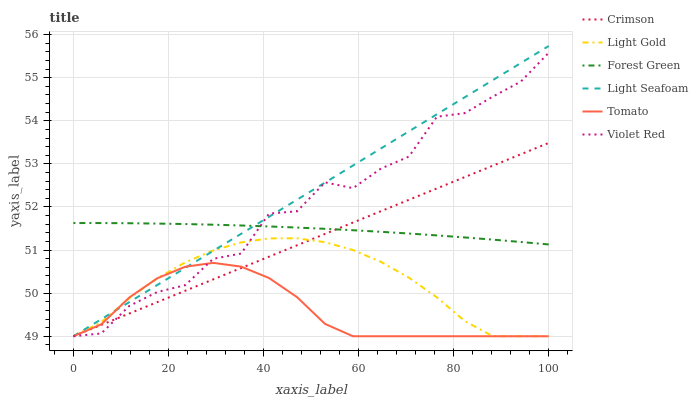Does Violet Red have the minimum area under the curve?
Answer yes or no. No. Does Violet Red have the maximum area under the curve?
Answer yes or no. No. Is Forest Green the smoothest?
Answer yes or no. No. Is Forest Green the roughest?
Answer yes or no. No. Does Forest Green have the lowest value?
Answer yes or no. No. Does Violet Red have the highest value?
Answer yes or no. No. Is Tomato less than Forest Green?
Answer yes or no. Yes. Is Forest Green greater than Tomato?
Answer yes or no. Yes. Does Tomato intersect Forest Green?
Answer yes or no. No. 